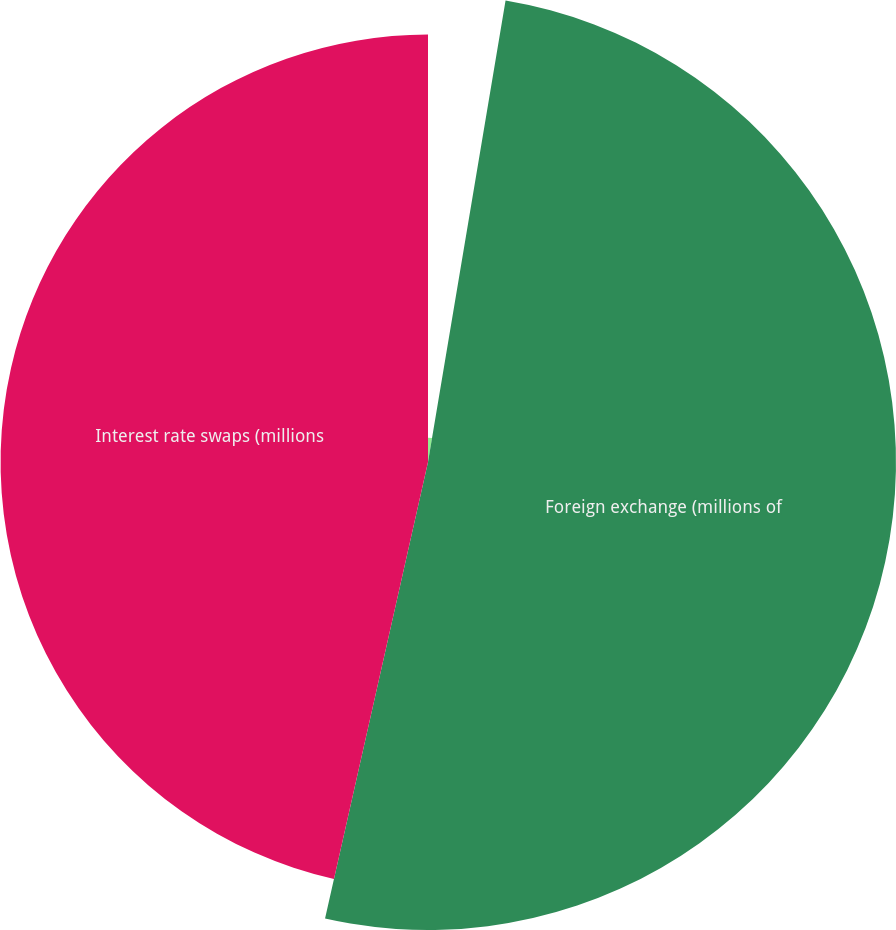Convert chart. <chart><loc_0><loc_0><loc_500><loc_500><pie_chart><fcel>Commodity primarily crude oil<fcel>Foreign exchange (millions of<fcel>Interest rate swaps (millions<nl><fcel>2.65%<fcel>50.88%<fcel>46.47%<nl></chart> 